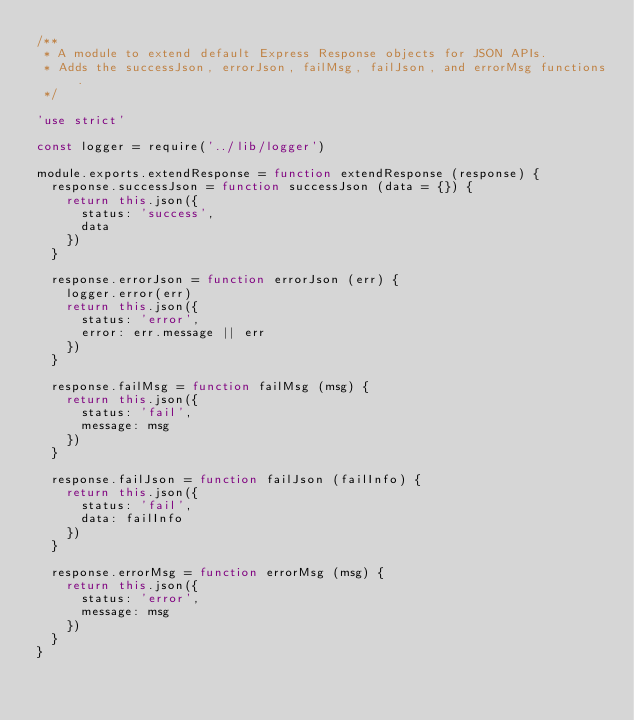Convert code to text. <code><loc_0><loc_0><loc_500><loc_500><_JavaScript_>/**
 * A module to extend default Express Response objects for JSON APIs.
 * Adds the successJson, errorJson, failMsg, failJson, and errorMsg functions.
 */

'use strict'

const logger = require('../lib/logger')

module.exports.extendResponse = function extendResponse (response) {
  response.successJson = function successJson (data = {}) {
    return this.json({
      status: 'success',
      data
    })
  }

  response.errorJson = function errorJson (err) {
    logger.error(err)
    return this.json({
      status: 'error',
      error: err.message || err
    })
  }

  response.failMsg = function failMsg (msg) {
    return this.json({
      status: 'fail',
      message: msg
    })
  }

  response.failJson = function failJson (failInfo) {
    return this.json({
      status: 'fail',
      data: failInfo
    })
  }

  response.errorMsg = function errorMsg (msg) {
    return this.json({
      status: 'error',
      message: msg
    })
  }
}
</code> 